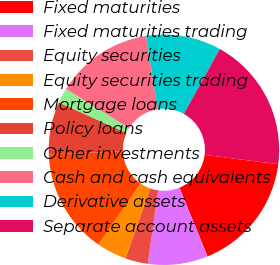<chart> <loc_0><loc_0><loc_500><loc_500><pie_chart><fcel>Fixed maturities<fcel>Fixed maturities trading<fcel>Equity securities<fcel>Equity securities trading<fcel>Mortgage loans<fcel>Policy loans<fcel>Other investments<fcel>Cash and cash equivalents<fcel>Derivative assets<fcel>Separate account assets<nl><fcel>16.83%<fcel>8.42%<fcel>3.17%<fcel>4.22%<fcel>14.73%<fcel>7.37%<fcel>2.12%<fcel>13.68%<fcel>10.53%<fcel>18.93%<nl></chart> 